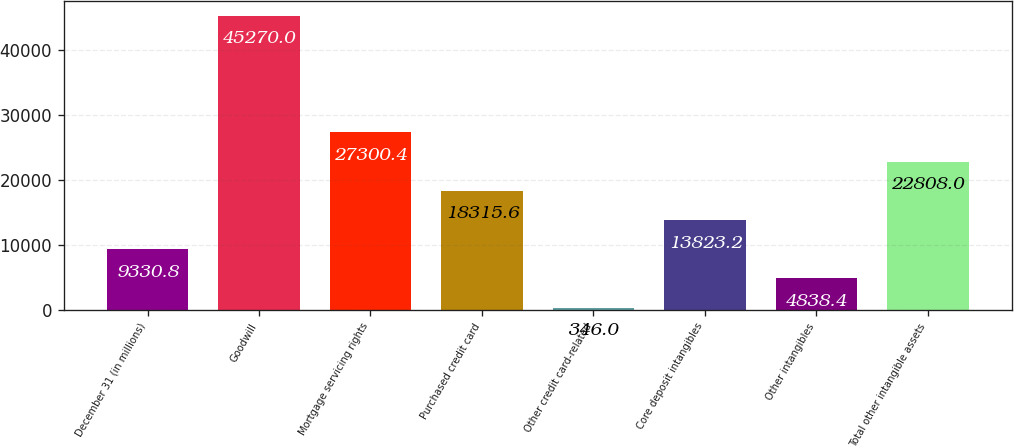<chart> <loc_0><loc_0><loc_500><loc_500><bar_chart><fcel>December 31 (in millions)<fcel>Goodwill<fcel>Mortgage servicing rights<fcel>Purchased credit card<fcel>Other credit card-related<fcel>Core deposit intangibles<fcel>Other intangibles<fcel>Total other intangible assets<nl><fcel>9330.8<fcel>45270<fcel>27300.4<fcel>18315.6<fcel>346<fcel>13823.2<fcel>4838.4<fcel>22808<nl></chart> 